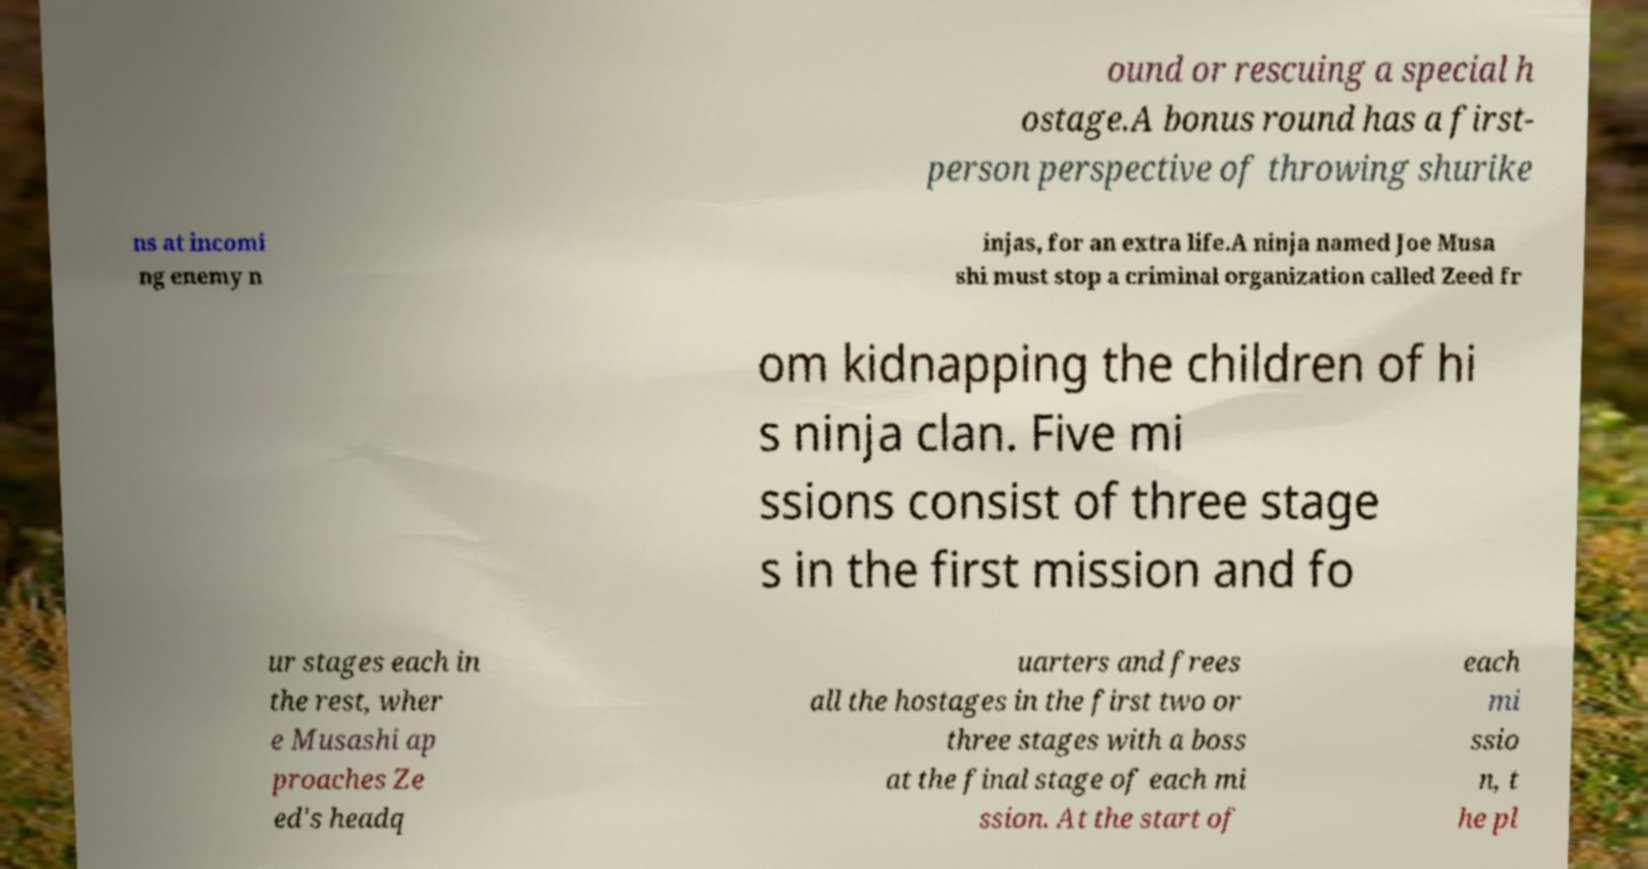Can you accurately transcribe the text from the provided image for me? ound or rescuing a special h ostage.A bonus round has a first- person perspective of throwing shurike ns at incomi ng enemy n injas, for an extra life.A ninja named Joe Musa shi must stop a criminal organization called Zeed fr om kidnapping the children of hi s ninja clan. Five mi ssions consist of three stage s in the first mission and fo ur stages each in the rest, wher e Musashi ap proaches Ze ed's headq uarters and frees all the hostages in the first two or three stages with a boss at the final stage of each mi ssion. At the start of each mi ssio n, t he pl 